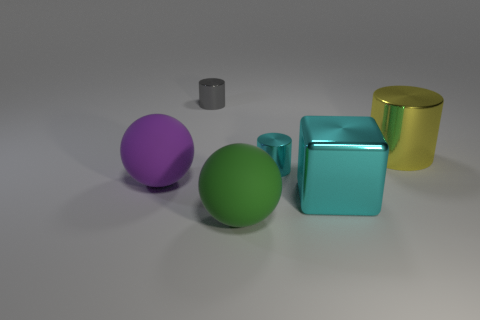Add 1 large rubber cylinders. How many objects exist? 7 Subtract all tiny gray cylinders. How many cylinders are left? 2 Subtract 1 blocks. How many blocks are left? 0 Subtract all cyan cylinders. How many cylinders are left? 2 Subtract 0 red cubes. How many objects are left? 6 Subtract all cubes. How many objects are left? 5 Subtract all brown cylinders. Subtract all blue cubes. How many cylinders are left? 3 Subtract all gray balls. How many gray cylinders are left? 1 Subtract all tiny cyan metal objects. Subtract all gray shiny cylinders. How many objects are left? 4 Add 4 big green rubber balls. How many big green rubber balls are left? 5 